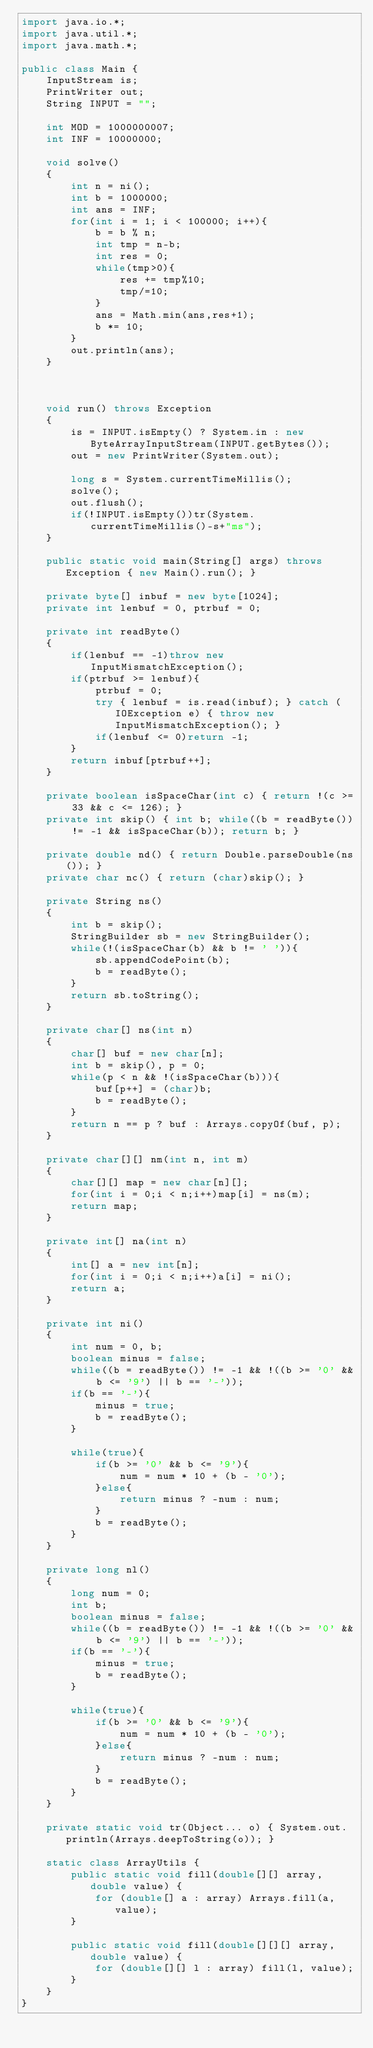Convert code to text. <code><loc_0><loc_0><loc_500><loc_500><_Java_>import java.io.*;
import java.util.*;
import java.math.*;

public class Main {
    InputStream is;
    PrintWriter out;
    String INPUT = "";

    int MOD = 1000000007;
    int INF = 10000000;

    void solve()
    {
        int n = ni();
        int b = 1000000;
        int ans = INF;
        for(int i = 1; i < 100000; i++){
            b = b % n;
            int tmp = n-b;
            int res = 0;
            while(tmp>0){
                res += tmp%10;
                tmp/=10;
            }
            ans = Math.min(ans,res+1);
            b *= 10;
        }
        out.println(ans);
    }

    
    
    void run() throws Exception
    {
        is = INPUT.isEmpty() ? System.in : new ByteArrayInputStream(INPUT.getBytes());
        out = new PrintWriter(System.out);
        
        long s = System.currentTimeMillis();
        solve();
        out.flush();
        if(!INPUT.isEmpty())tr(System.currentTimeMillis()-s+"ms");
    }
    
    public static void main(String[] args) throws Exception { new Main().run(); }
    
    private byte[] inbuf = new byte[1024];
    private int lenbuf = 0, ptrbuf = 0;
    
    private int readByte()
    {
        if(lenbuf == -1)throw new InputMismatchException();
        if(ptrbuf >= lenbuf){
            ptrbuf = 0;
            try { lenbuf = is.read(inbuf); } catch (IOException e) { throw new InputMismatchException(); }
            if(lenbuf <= 0)return -1;
        }
        return inbuf[ptrbuf++];
    }
    
    private boolean isSpaceChar(int c) { return !(c >= 33 && c <= 126); }
    private int skip() { int b; while((b = readByte()) != -1 && isSpaceChar(b)); return b; }
    
    private double nd() { return Double.parseDouble(ns()); }
    private char nc() { return (char)skip(); }
    
    private String ns()
    {
        int b = skip();
        StringBuilder sb = new StringBuilder();
        while(!(isSpaceChar(b) && b != ' ')){
            sb.appendCodePoint(b);
            b = readByte();
        }
        return sb.toString();
    }
    
    private char[] ns(int n)
    {
        char[] buf = new char[n];
        int b = skip(), p = 0;
        while(p < n && !(isSpaceChar(b))){
            buf[p++] = (char)b;
            b = readByte();
        }
        return n == p ? buf : Arrays.copyOf(buf, p);
    }
    
    private char[][] nm(int n, int m)
    {
        char[][] map = new char[n][];
        for(int i = 0;i < n;i++)map[i] = ns(m);
        return map;
    }
    
    private int[] na(int n)
    {
        int[] a = new int[n];
        for(int i = 0;i < n;i++)a[i] = ni();
        return a;
    }
    
    private int ni()
    {
        int num = 0, b;
        boolean minus = false;
        while((b = readByte()) != -1 && !((b >= '0' && b <= '9') || b == '-'));
        if(b == '-'){
            minus = true;
            b = readByte();
        }
        
        while(true){
            if(b >= '0' && b <= '9'){
                num = num * 10 + (b - '0');
            }else{
                return minus ? -num : num;
            }
            b = readByte();
        }
    }
    
    private long nl()
    {
        long num = 0;
        int b;
        boolean minus = false;
        while((b = readByte()) != -1 && !((b >= '0' && b <= '9') || b == '-'));
        if(b == '-'){
            minus = true;
            b = readByte();
        }
        
        while(true){
            if(b >= '0' && b <= '9'){
                num = num * 10 + (b - '0');
            }else{
                return minus ? -num : num;
            }
            b = readByte();
        }
    }
    
    private static void tr(Object... o) { System.out.println(Arrays.deepToString(o)); }

    static class ArrayUtils {
        public static void fill(double[][] array, double value) {
            for (double[] a : array) Arrays.fill(a, value);
        }
 
        public static void fill(double[][][] array, double value) {
            for (double[][] l : array) fill(l, value);
        } 
    }
}
</code> 